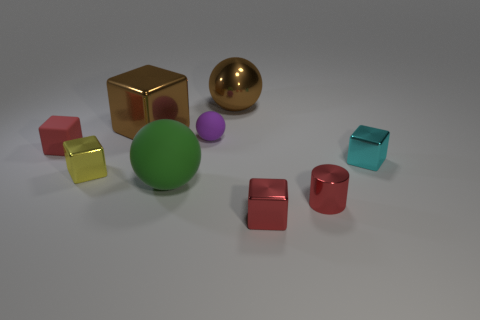What shape is the yellow metallic object? The yellow metallic object in the image has a cubic shape, with equal edges and square faces that reflect the light distinctly, creating a polished metallic appearance. 